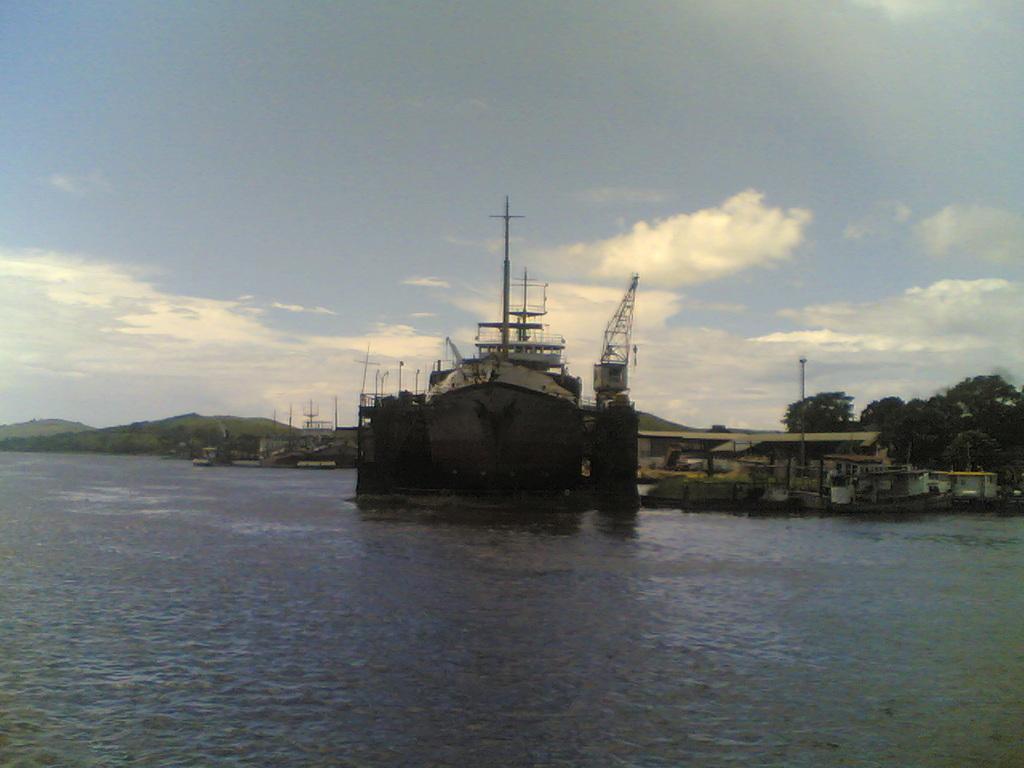Could you give a brief overview of what you see in this image? In this image I can see water and in it I can see a ship. In the background I can see number of trees, clouds and sky. I can also see few poles in background. 